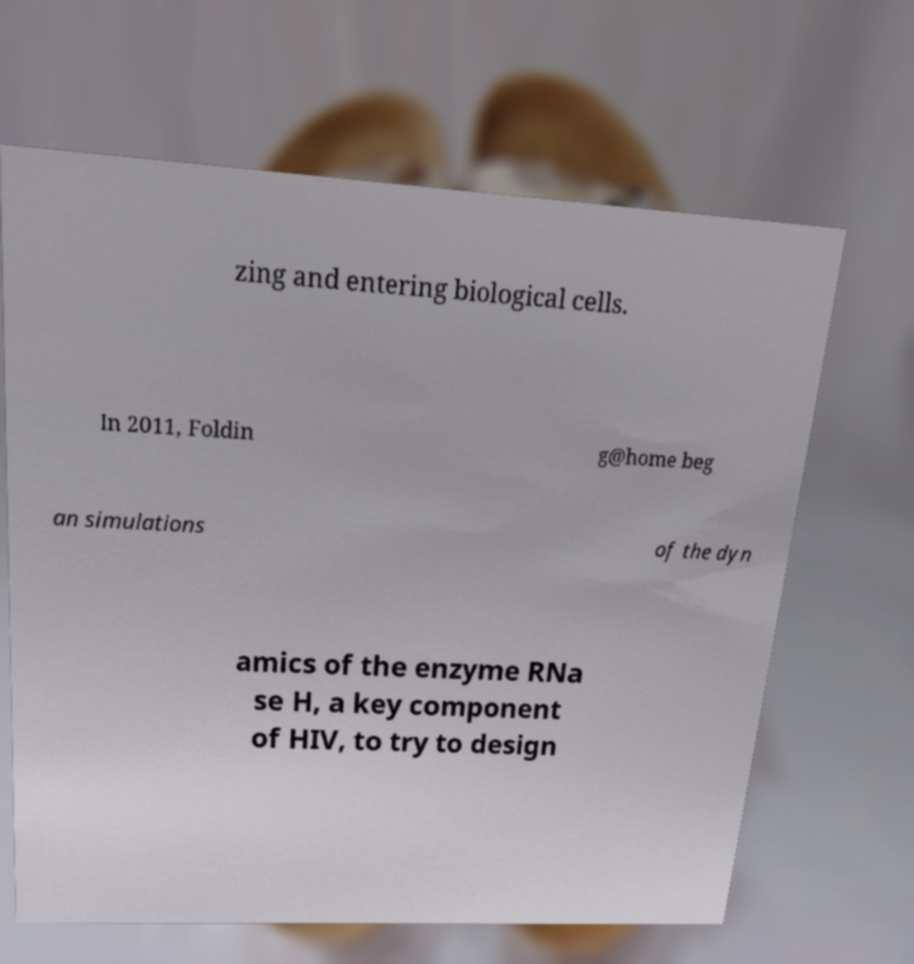What messages or text are displayed in this image? I need them in a readable, typed format. zing and entering biological cells. In 2011, Foldin g@home beg an simulations of the dyn amics of the enzyme RNa se H, a key component of HIV, to try to design 